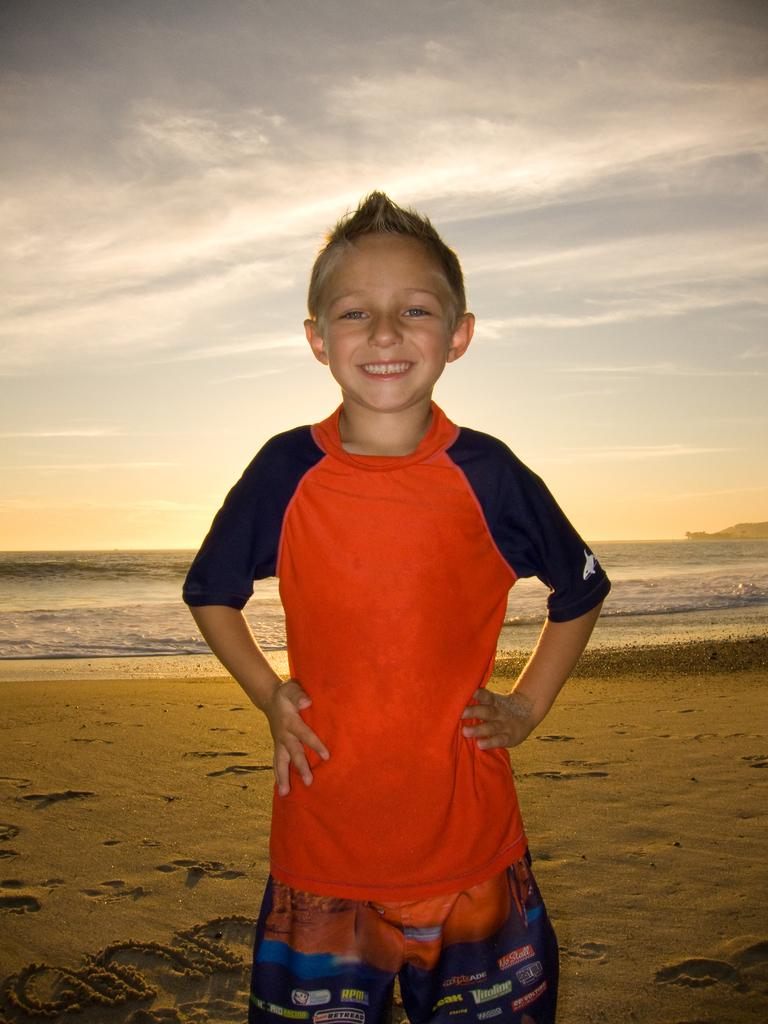Who is present in the image? There is a boy in the image. What is the boy wearing? The boy is wearing a dress. Where is the boy located in the image? The boy is standing on the shore. What can be seen in the background of the image? There is water and a cloudy sky visible in the background of the image. What type of plough is the boy using to drive in the image? There is no plough or driving activity present in the image; the boy is standing on the shore. 